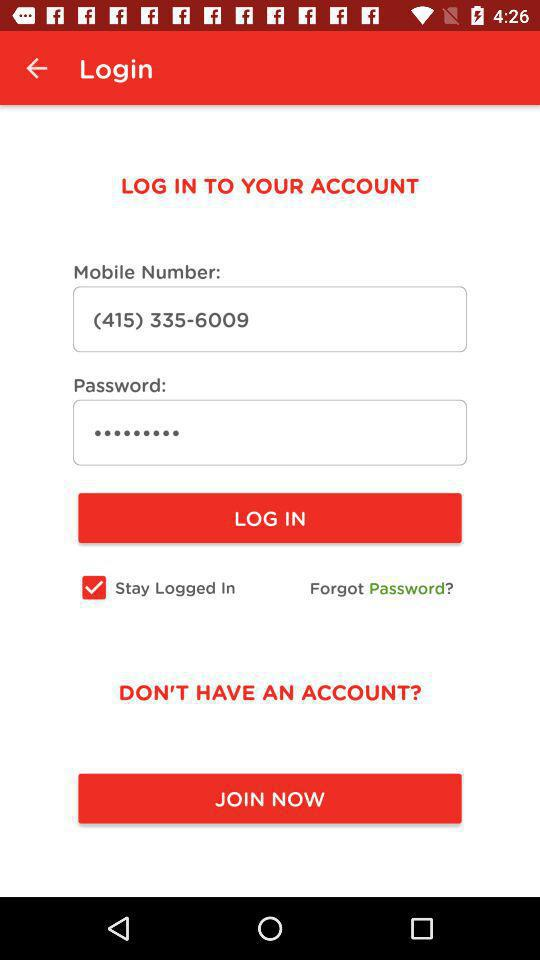What is the status of "Stay Logged In"? The status of "Stay Logged In" is "on". 